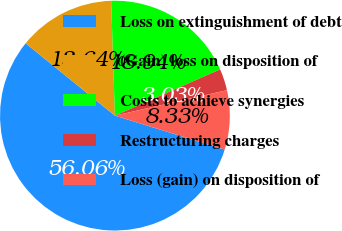<chart> <loc_0><loc_0><loc_500><loc_500><pie_chart><fcel>Loss on extinguishment of debt<fcel>(Gain) loss on disposition of<fcel>Costs to achieve synergies<fcel>Restructuring charges<fcel>Loss (gain) on disposition of<nl><fcel>56.06%<fcel>13.64%<fcel>18.94%<fcel>3.03%<fcel>8.33%<nl></chart> 